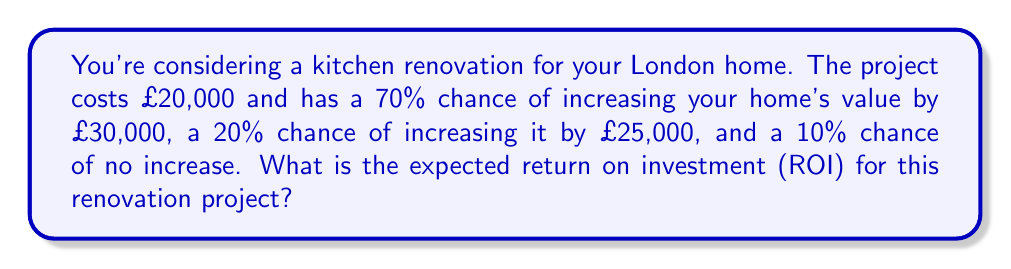Could you help me with this problem? Let's approach this step-by-step:

1) First, we need to calculate the expected value (EV) of the home value increase:

   $EV = (0.70 \times £30,000) + (0.20 \times £25,000) + (0.10 \times £0)$
   $EV = £21,000 + £5,000 + £0 = £26,000$

2) Now, we can calculate the net profit by subtracting the cost of the renovation:

   Net Profit = Expected Value - Cost
   $Net Profit = £26,000 - £20,000 = £6,000$

3) The Return on Investment (ROI) is calculated as:

   $ROI = \frac{Net Profit}{Cost} \times 100\%$

4) Plugging in our values:

   $ROI = \frac{£6,000}{£20,000} \times 100\% = 0.3 \times 100\% = 30\%$

Therefore, the expected ROI for this kitchen renovation project is 30%.
Answer: 30% 